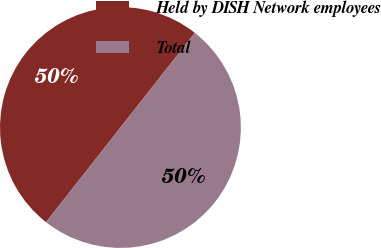Convert chart. <chart><loc_0><loc_0><loc_500><loc_500><pie_chart><fcel>Held by DISH Network employees<fcel>Total<nl><fcel>50.0%<fcel>50.0%<nl></chart> 